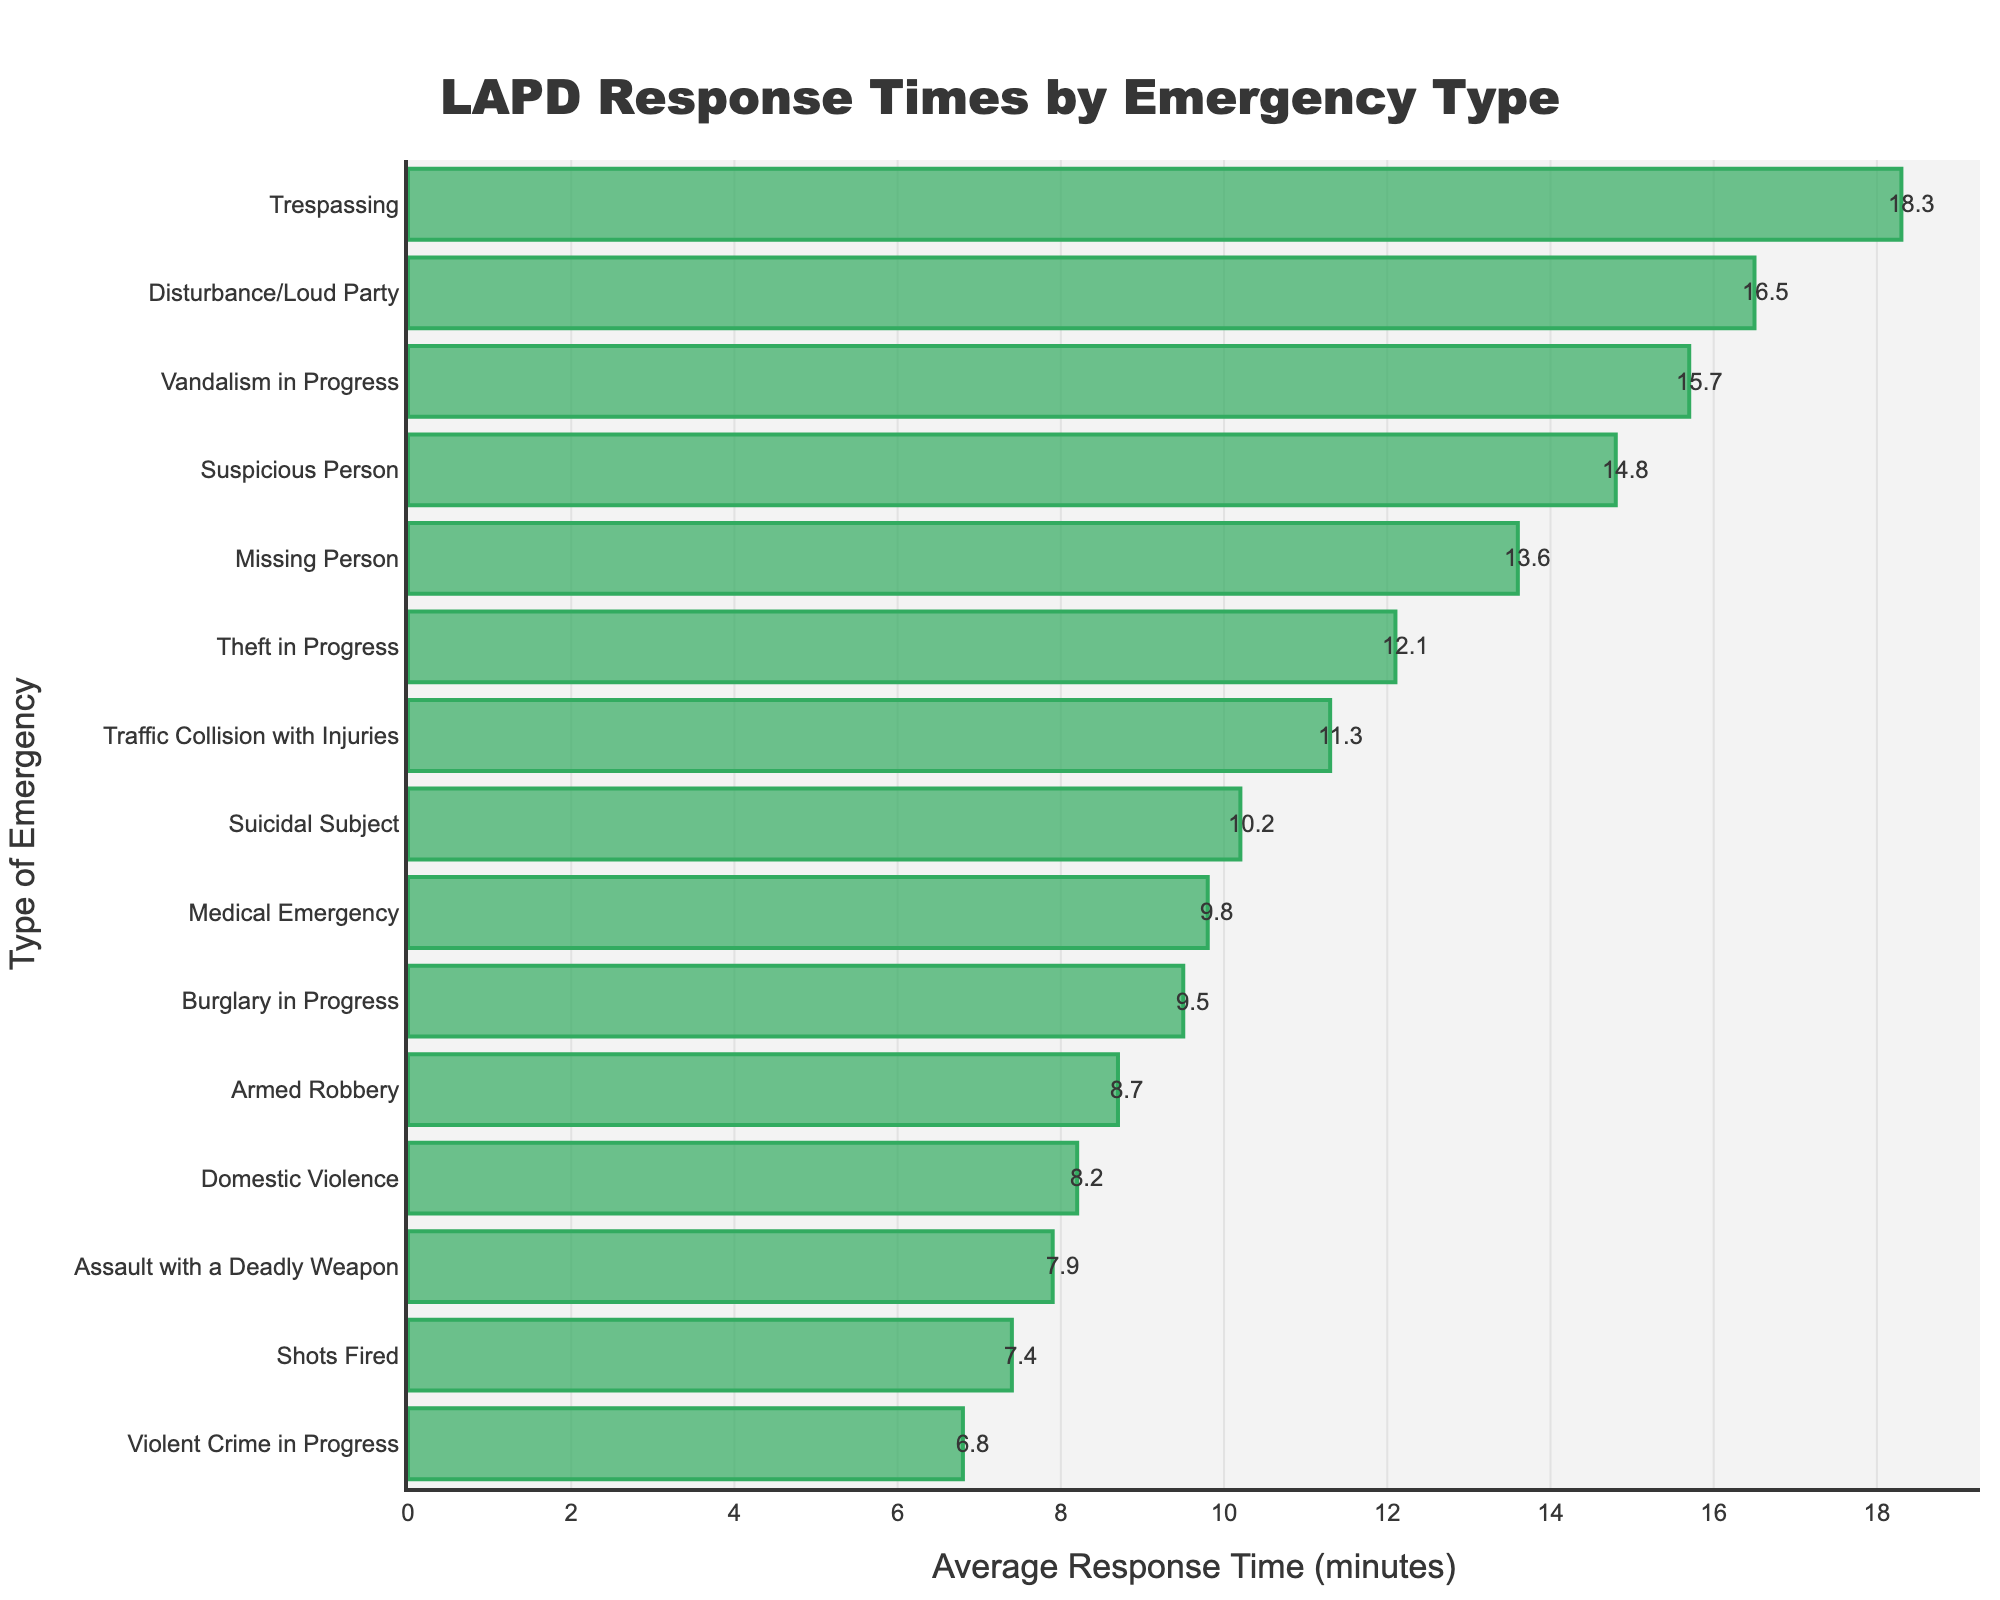What's the type of emergency with the fastest average response time? The shortest bar represents the fastest response time. For this bar, the corresponding type of emergency is 'Violent Crime in Progress' with an average response time of 6.8 minutes.
Answer: Violent Crime in Progress Which type of emergency has the longest average response time, and what is that time? The longest bar represents the longest response time. For this bar, the corresponding type of emergency is 'Trespassing' with an average response time of 18.3 minutes.
Answer: Trespassing, 18.3 minutes What's the average response time for 'Armed Robbery' and 'Assault with a Deadly Weapon'? The average response times for 'Armed Robbery' and 'Assault with a Deadly Weapon' are 8.7 and 7.9 minutes respectively. The average of these two numbers is (8.7 + 7.9) / 2 = 8.3 minutes.
Answer: 8.3 minutes What is the difference in response time between 'Shots Fired' and 'Suicidal Subject'? First, note the response times for each emergency type: 'Shots Fired' is 7.4 minutes and 'Suicidal Subject' is 10.2 minutes. The difference is 10.2 - 7.4 = 2.8 minutes.
Answer: 2.8 minutes Are there any types of emergencies with average response times greater than 15 minutes? If so, which ones? By examining the bars, the types of emergencies with average response times greater than 15 minutes are 'Disturbance/Loud Party', 'Trespassing', and 'Vandalism in Progress'.
Answer: Yes, Disturbance/Loud Party, Trespassing, Vandalism in Progress What's the combined average response time for 'Burglary in Progress', 'Traffic Collision with Injuries', and 'Medical Emergency'? The average response times for 'Burglary in Progress', 'Traffic Collision with Injuries', and 'Medical Emergency' are 9.5, 11.3, and 9.8 minutes respectively. The combined average is (9.5 + 11.3 + 9.8) / 3 = 10.2 minutes.
Answer: 10.2 minutes Which has a longer average response time: 'Theft in Progress' or 'Suspicious Person'? 'Theft in Progress' has an average response time of 12.1 minutes, while 'Suspicious Person' has an average of 14.8 minutes. Therefore, 'Suspicious Person' has a longer average response time.
Answer: Suspicious Person What's the visual difference between the bar for 'Violent Crime in Progress' and 'Disturbance/Loud Party'? 'Violent Crime in Progress' has the shortest bar indicating the quickest response time, while 'Disturbance/Loud Party' has one of the longest bars indicating a much slower response time.
Answer: 'Violent Crime in Progress' is shorter How much longer is the average response time for 'Trespassing' compared to 'Missing Person'? 'Trespassing' has an average response time of 18.3 minutes, and 'Missing Person' has 13.6 minutes. The difference is 18.3 - 13.6 = 4.7 minutes.
Answer: 4.7 minutes 